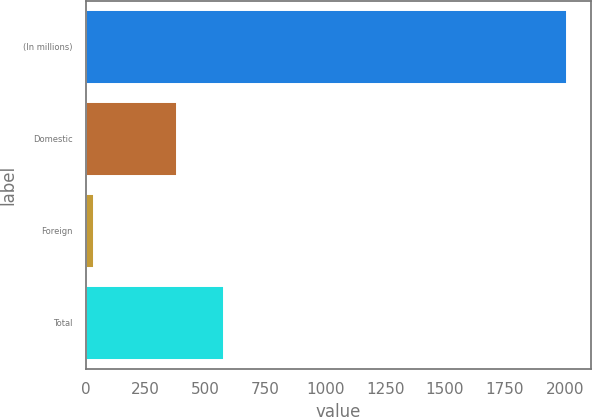Convert chart. <chart><loc_0><loc_0><loc_500><loc_500><bar_chart><fcel>(In millions)<fcel>Domestic<fcel>Foreign<fcel>Total<nl><fcel>2010<fcel>382.2<fcel>36.1<fcel>579.59<nl></chart> 